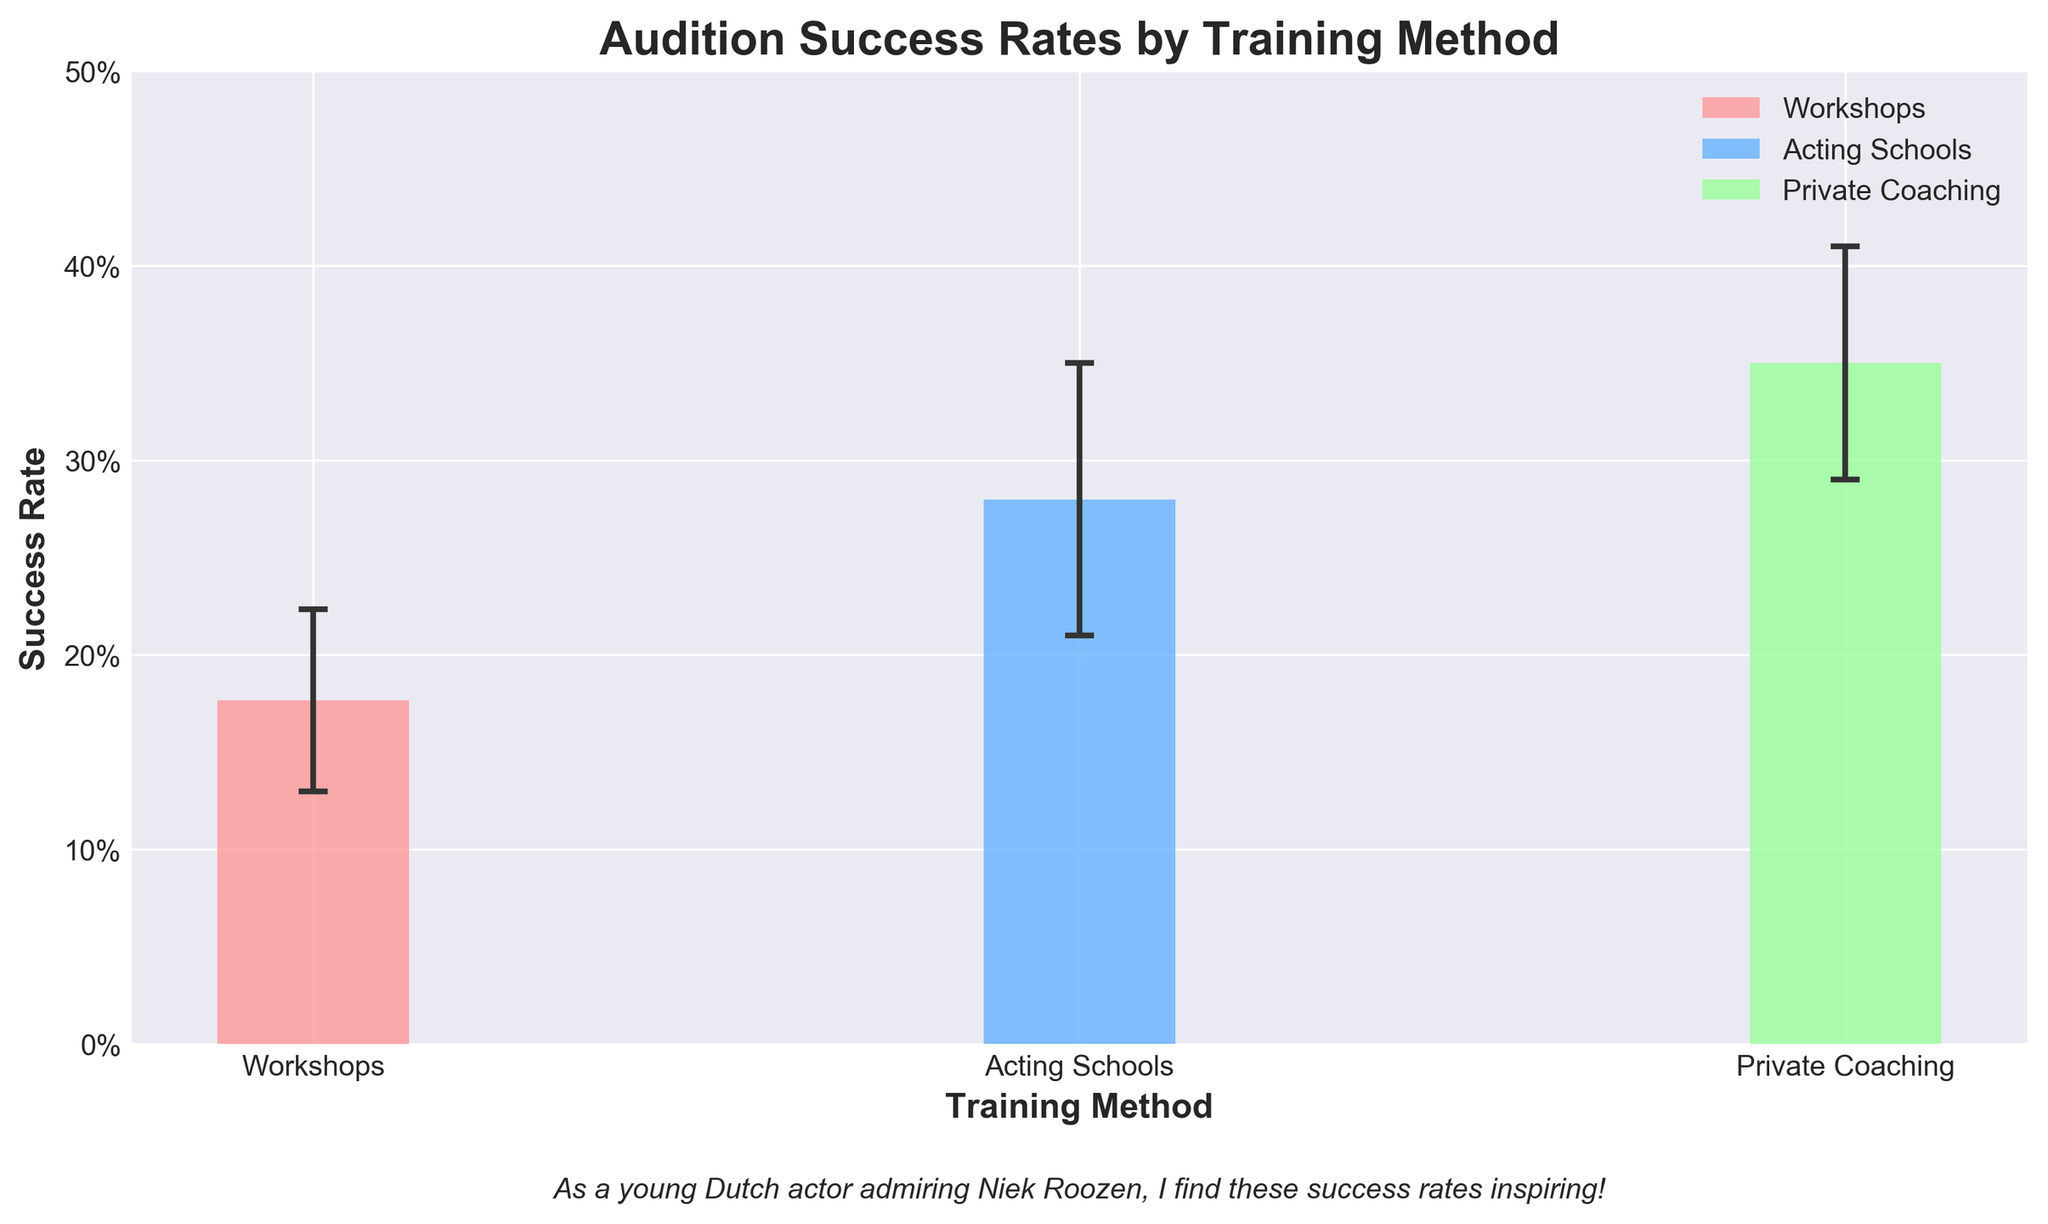What is the title of the plot? The title is located at the top of the plot and is descriptive of the figure's content. It reads "Audition Success Rates by Training Method."
Answer: Audition Success Rates by Training Method Which training method has the highest average success rate? By comparing the bar heights, Private Coaching has the highest average success rate.
Answer: Private Coaching Which training method has the lowest average success rate? By comparing the bar heights, Workshops have the lowest average success rate.
Answer: Workshops What is the average success rate for Acting Schools? Locate the bar representing Acting Schools and read its height. The height represents the average success rate, approximately 0.28 or 28%.
Answer: 28% How does the error bar for Private Coaching compare to that for Acting Schools? The error bars are visual indicators of variability. The error bar for Private Coaching appears slightly smaller than that for Acting Schools.
Answer: Smaller What is the range of success rates displayed in the plot? The y-axis shows success rates from 0 to 0.5, with the bars reaching up to around 0.40 at maximum and 0.15 at minimum.
Answer: 0.15 to 0.40 How does the success rate for Private Coaching compare to that for Workshops? Compare the heights of the bars for both methods. Private Coaching has a significantly higher success rate than Workshops.
Answer: Higher By how much does the average success rate for Acting Schools exceed that for Workshops? Subtract the average success rate of Workshops from that of Acting Schools (0.28 - 0.18). This indicates an approximate difference of 0.10 or 10%.
Answer: 10% What can be inferred from the error bars about the consistency of training methods? Smaller error bars indicate more consistency. Thus, Acting Schools show more variability than both Workshops and Private Coaching.
Answer: Acting Schools less consistent What general trend can be observed in the success rates across different training methods? Private Coaching generally has the highest success rates, followed by Acting Schools, and then Workshops. This trend is consistent across the different bars.
Answer: Private Coaching > Acting Schools > Workshops 